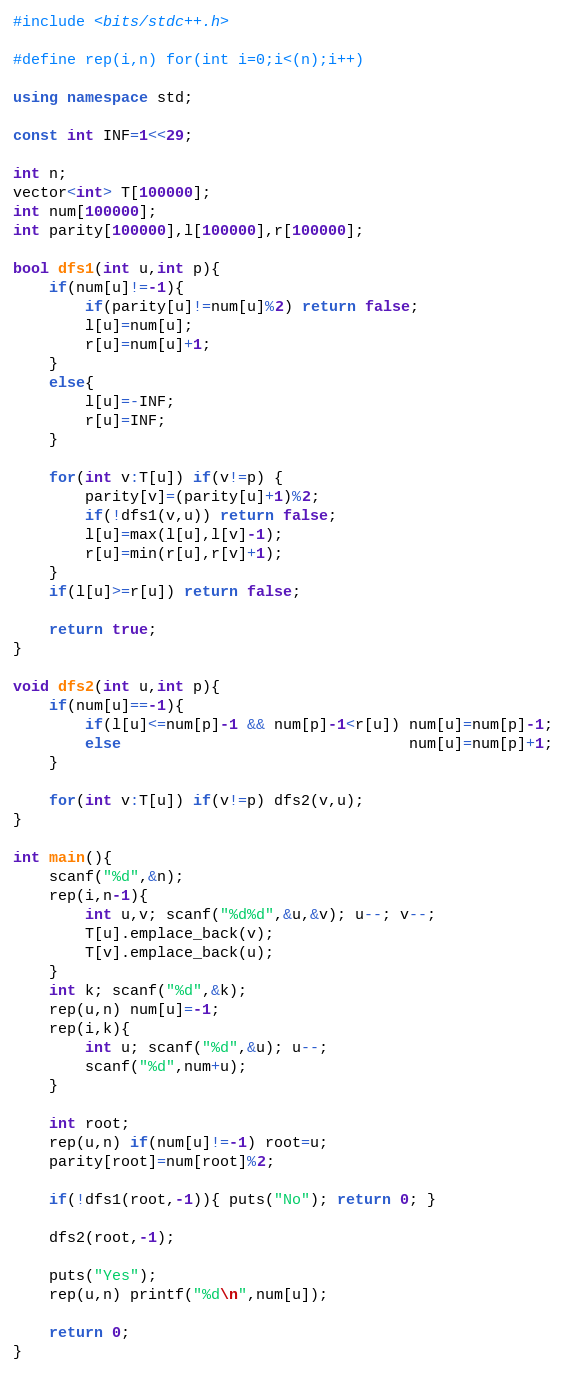Convert code to text. <code><loc_0><loc_0><loc_500><loc_500><_C++_>#include <bits/stdc++.h>

#define rep(i,n) for(int i=0;i<(n);i++)

using namespace std;

const int INF=1<<29;

int n;
vector<int> T[100000];
int num[100000];
int parity[100000],l[100000],r[100000];

bool dfs1(int u,int p){
	if(num[u]!=-1){
		if(parity[u]!=num[u]%2) return false;
		l[u]=num[u];
		r[u]=num[u]+1;
	}
	else{
		l[u]=-INF;
		r[u]=INF;
	}

	for(int v:T[u]) if(v!=p) {
		parity[v]=(parity[u]+1)%2;
		if(!dfs1(v,u)) return false;
		l[u]=max(l[u],l[v]-1);
		r[u]=min(r[u],r[v]+1);
	}
	if(l[u]>=r[u]) return false;

	return true;
}

void dfs2(int u,int p){
	if(num[u]==-1){
		if(l[u]<=num[p]-1 && num[p]-1<r[u]) num[u]=num[p]-1;
		else                                num[u]=num[p]+1;
	}

	for(int v:T[u]) if(v!=p) dfs2(v,u);
}

int main(){
	scanf("%d",&n);
	rep(i,n-1){
		int u,v; scanf("%d%d",&u,&v); u--; v--;
		T[u].emplace_back(v);
		T[v].emplace_back(u);
	}
	int k; scanf("%d",&k);
	rep(u,n) num[u]=-1;
	rep(i,k){
		int u; scanf("%d",&u); u--;
		scanf("%d",num+u);
	}

	int root;
	rep(u,n) if(num[u]!=-1) root=u;
	parity[root]=num[root]%2;

	if(!dfs1(root,-1)){ puts("No"); return 0; }

	dfs2(root,-1);

	puts("Yes");
	rep(u,n) printf("%d\n",num[u]);

	return 0;
}
</code> 